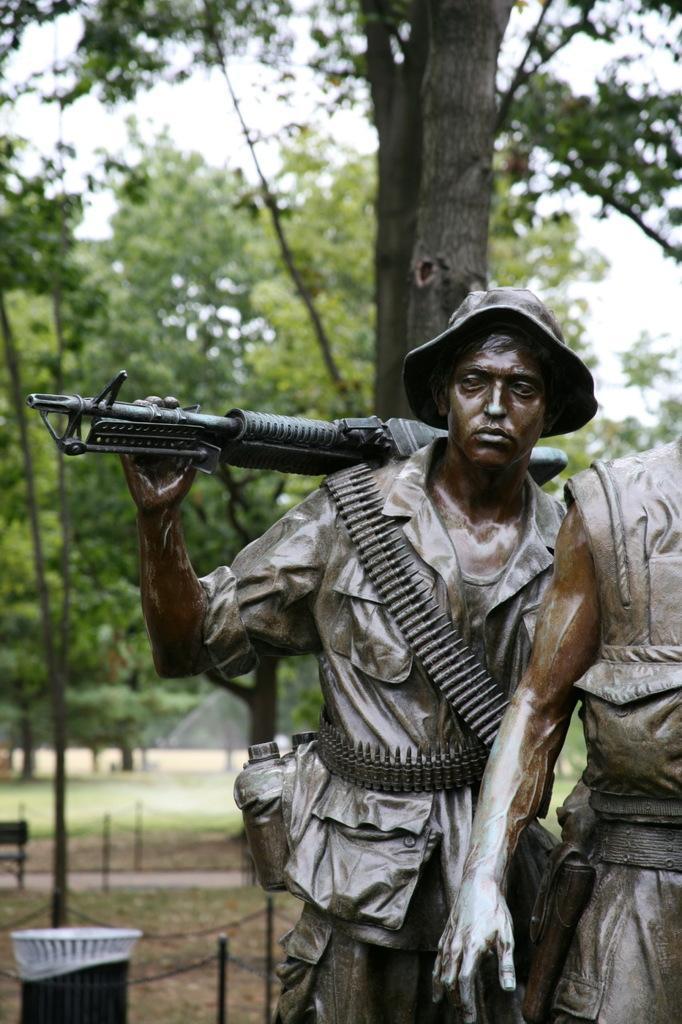Could you give a brief overview of what you see in this image? In this image there is the sky towards the top of the image, there are trees, there is a fence, there is an object towards the left of the image, there is a dustbin towards the bottom of the image, there is ground towards the bottom of the image, there are sculptors towards the right of the image, there is a man holding a gun, he is wearing a hat. 